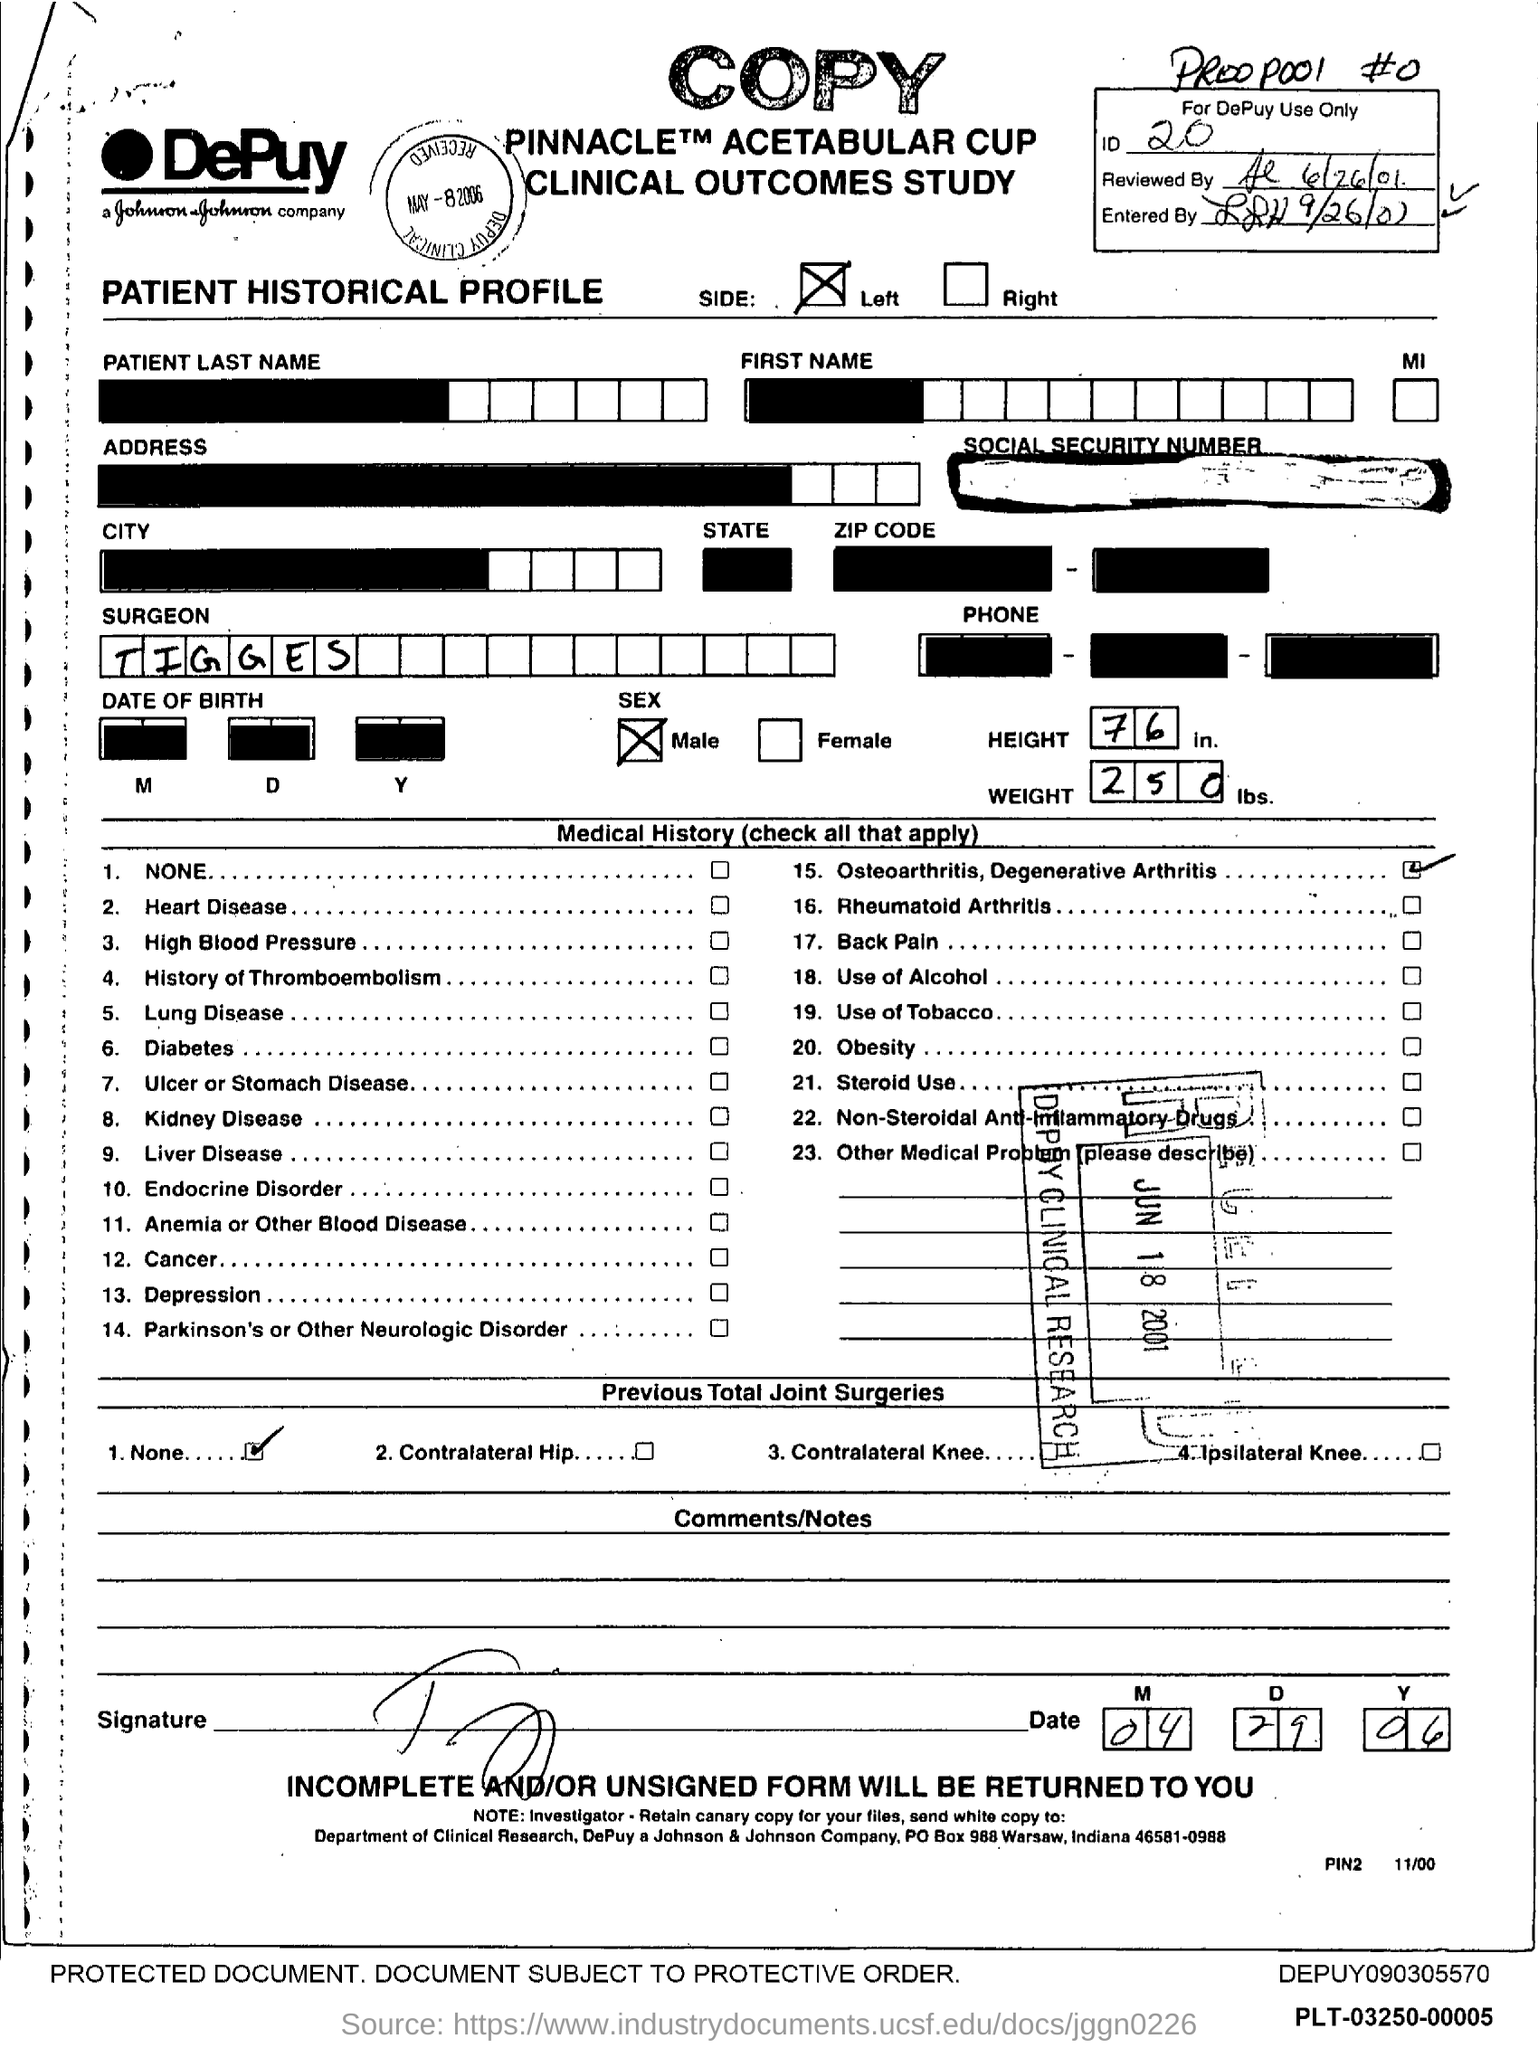What is the ID Number?
Give a very brief answer. 20. What is the name of the Surgeon?
Keep it short and to the point. Tigges. What is the height?
Your answer should be compact. 76. What is the Weight?
Provide a succinct answer. 250. 